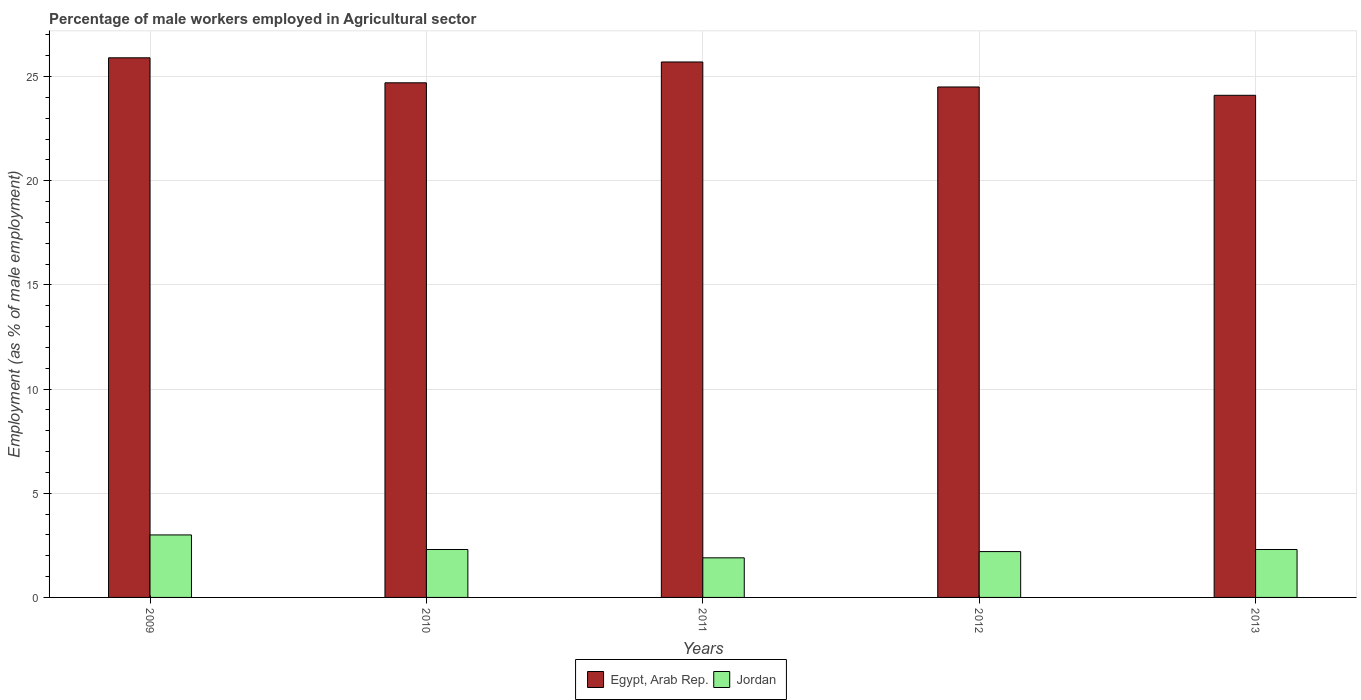How many different coloured bars are there?
Ensure brevity in your answer.  2. Are the number of bars on each tick of the X-axis equal?
Provide a succinct answer. Yes. How many bars are there on the 1st tick from the left?
Keep it short and to the point. 2. What is the percentage of male workers employed in Agricultural sector in Jordan in 2013?
Offer a terse response. 2.3. Across all years, what is the maximum percentage of male workers employed in Agricultural sector in Jordan?
Ensure brevity in your answer.  3. Across all years, what is the minimum percentage of male workers employed in Agricultural sector in Jordan?
Give a very brief answer. 1.9. What is the total percentage of male workers employed in Agricultural sector in Jordan in the graph?
Your response must be concise. 11.7. What is the difference between the percentage of male workers employed in Agricultural sector in Egypt, Arab Rep. in 2009 and that in 2012?
Offer a terse response. 1.4. What is the difference between the percentage of male workers employed in Agricultural sector in Jordan in 2010 and the percentage of male workers employed in Agricultural sector in Egypt, Arab Rep. in 2009?
Give a very brief answer. -23.6. What is the average percentage of male workers employed in Agricultural sector in Egypt, Arab Rep. per year?
Your answer should be very brief. 24.98. In the year 2010, what is the difference between the percentage of male workers employed in Agricultural sector in Jordan and percentage of male workers employed in Agricultural sector in Egypt, Arab Rep.?
Make the answer very short. -22.4. What is the difference between the highest and the second highest percentage of male workers employed in Agricultural sector in Jordan?
Offer a terse response. 0.7. What is the difference between the highest and the lowest percentage of male workers employed in Agricultural sector in Egypt, Arab Rep.?
Make the answer very short. 1.8. In how many years, is the percentage of male workers employed in Agricultural sector in Jordan greater than the average percentage of male workers employed in Agricultural sector in Jordan taken over all years?
Your answer should be compact. 1. What does the 1st bar from the left in 2009 represents?
Give a very brief answer. Egypt, Arab Rep. What does the 2nd bar from the right in 2010 represents?
Offer a very short reply. Egypt, Arab Rep. Are the values on the major ticks of Y-axis written in scientific E-notation?
Provide a short and direct response. No. How many legend labels are there?
Your answer should be very brief. 2. How are the legend labels stacked?
Provide a short and direct response. Horizontal. What is the title of the graph?
Ensure brevity in your answer.  Percentage of male workers employed in Agricultural sector. What is the label or title of the Y-axis?
Offer a terse response. Employment (as % of male employment). What is the Employment (as % of male employment) of Egypt, Arab Rep. in 2009?
Ensure brevity in your answer.  25.9. What is the Employment (as % of male employment) of Egypt, Arab Rep. in 2010?
Your answer should be compact. 24.7. What is the Employment (as % of male employment) of Jordan in 2010?
Make the answer very short. 2.3. What is the Employment (as % of male employment) in Egypt, Arab Rep. in 2011?
Make the answer very short. 25.7. What is the Employment (as % of male employment) in Jordan in 2011?
Keep it short and to the point. 1.9. What is the Employment (as % of male employment) of Jordan in 2012?
Offer a very short reply. 2.2. What is the Employment (as % of male employment) in Egypt, Arab Rep. in 2013?
Give a very brief answer. 24.1. What is the Employment (as % of male employment) of Jordan in 2013?
Your answer should be very brief. 2.3. Across all years, what is the maximum Employment (as % of male employment) in Egypt, Arab Rep.?
Ensure brevity in your answer.  25.9. Across all years, what is the minimum Employment (as % of male employment) in Egypt, Arab Rep.?
Ensure brevity in your answer.  24.1. Across all years, what is the minimum Employment (as % of male employment) of Jordan?
Your response must be concise. 1.9. What is the total Employment (as % of male employment) of Egypt, Arab Rep. in the graph?
Make the answer very short. 124.9. What is the total Employment (as % of male employment) in Jordan in the graph?
Provide a short and direct response. 11.7. What is the difference between the Employment (as % of male employment) of Egypt, Arab Rep. in 2009 and that in 2010?
Your response must be concise. 1.2. What is the difference between the Employment (as % of male employment) in Egypt, Arab Rep. in 2009 and that in 2011?
Make the answer very short. 0.2. What is the difference between the Employment (as % of male employment) of Egypt, Arab Rep. in 2009 and that in 2012?
Your answer should be very brief. 1.4. What is the difference between the Employment (as % of male employment) in Jordan in 2009 and that in 2013?
Give a very brief answer. 0.7. What is the difference between the Employment (as % of male employment) in Jordan in 2010 and that in 2011?
Your answer should be compact. 0.4. What is the difference between the Employment (as % of male employment) of Jordan in 2010 and that in 2013?
Provide a succinct answer. 0. What is the difference between the Employment (as % of male employment) of Egypt, Arab Rep. in 2011 and that in 2012?
Provide a succinct answer. 1.2. What is the difference between the Employment (as % of male employment) of Egypt, Arab Rep. in 2011 and that in 2013?
Ensure brevity in your answer.  1.6. What is the difference between the Employment (as % of male employment) in Jordan in 2011 and that in 2013?
Your answer should be very brief. -0.4. What is the difference between the Employment (as % of male employment) of Egypt, Arab Rep. in 2009 and the Employment (as % of male employment) of Jordan in 2010?
Give a very brief answer. 23.6. What is the difference between the Employment (as % of male employment) in Egypt, Arab Rep. in 2009 and the Employment (as % of male employment) in Jordan in 2012?
Your response must be concise. 23.7. What is the difference between the Employment (as % of male employment) of Egypt, Arab Rep. in 2009 and the Employment (as % of male employment) of Jordan in 2013?
Make the answer very short. 23.6. What is the difference between the Employment (as % of male employment) of Egypt, Arab Rep. in 2010 and the Employment (as % of male employment) of Jordan in 2011?
Offer a very short reply. 22.8. What is the difference between the Employment (as % of male employment) of Egypt, Arab Rep. in 2010 and the Employment (as % of male employment) of Jordan in 2013?
Offer a terse response. 22.4. What is the difference between the Employment (as % of male employment) of Egypt, Arab Rep. in 2011 and the Employment (as % of male employment) of Jordan in 2013?
Keep it short and to the point. 23.4. What is the difference between the Employment (as % of male employment) in Egypt, Arab Rep. in 2012 and the Employment (as % of male employment) in Jordan in 2013?
Offer a terse response. 22.2. What is the average Employment (as % of male employment) in Egypt, Arab Rep. per year?
Offer a very short reply. 24.98. What is the average Employment (as % of male employment) in Jordan per year?
Ensure brevity in your answer.  2.34. In the year 2009, what is the difference between the Employment (as % of male employment) in Egypt, Arab Rep. and Employment (as % of male employment) in Jordan?
Offer a very short reply. 22.9. In the year 2010, what is the difference between the Employment (as % of male employment) of Egypt, Arab Rep. and Employment (as % of male employment) of Jordan?
Provide a succinct answer. 22.4. In the year 2011, what is the difference between the Employment (as % of male employment) of Egypt, Arab Rep. and Employment (as % of male employment) of Jordan?
Provide a short and direct response. 23.8. In the year 2012, what is the difference between the Employment (as % of male employment) of Egypt, Arab Rep. and Employment (as % of male employment) of Jordan?
Provide a short and direct response. 22.3. In the year 2013, what is the difference between the Employment (as % of male employment) of Egypt, Arab Rep. and Employment (as % of male employment) of Jordan?
Your answer should be very brief. 21.8. What is the ratio of the Employment (as % of male employment) of Egypt, Arab Rep. in 2009 to that in 2010?
Offer a terse response. 1.05. What is the ratio of the Employment (as % of male employment) of Jordan in 2009 to that in 2010?
Your answer should be compact. 1.3. What is the ratio of the Employment (as % of male employment) in Jordan in 2009 to that in 2011?
Provide a short and direct response. 1.58. What is the ratio of the Employment (as % of male employment) in Egypt, Arab Rep. in 2009 to that in 2012?
Offer a terse response. 1.06. What is the ratio of the Employment (as % of male employment) in Jordan in 2009 to that in 2012?
Provide a short and direct response. 1.36. What is the ratio of the Employment (as % of male employment) of Egypt, Arab Rep. in 2009 to that in 2013?
Provide a succinct answer. 1.07. What is the ratio of the Employment (as % of male employment) in Jordan in 2009 to that in 2013?
Offer a very short reply. 1.3. What is the ratio of the Employment (as % of male employment) in Egypt, Arab Rep. in 2010 to that in 2011?
Your answer should be compact. 0.96. What is the ratio of the Employment (as % of male employment) in Jordan in 2010 to that in 2011?
Offer a very short reply. 1.21. What is the ratio of the Employment (as % of male employment) of Egypt, Arab Rep. in 2010 to that in 2012?
Your answer should be very brief. 1.01. What is the ratio of the Employment (as % of male employment) in Jordan in 2010 to that in 2012?
Keep it short and to the point. 1.05. What is the ratio of the Employment (as % of male employment) of Egypt, Arab Rep. in 2010 to that in 2013?
Ensure brevity in your answer.  1.02. What is the ratio of the Employment (as % of male employment) of Egypt, Arab Rep. in 2011 to that in 2012?
Make the answer very short. 1.05. What is the ratio of the Employment (as % of male employment) in Jordan in 2011 to that in 2012?
Provide a succinct answer. 0.86. What is the ratio of the Employment (as % of male employment) of Egypt, Arab Rep. in 2011 to that in 2013?
Make the answer very short. 1.07. What is the ratio of the Employment (as % of male employment) in Jordan in 2011 to that in 2013?
Offer a very short reply. 0.83. What is the ratio of the Employment (as % of male employment) in Egypt, Arab Rep. in 2012 to that in 2013?
Your answer should be very brief. 1.02. What is the ratio of the Employment (as % of male employment) of Jordan in 2012 to that in 2013?
Your answer should be compact. 0.96. What is the difference between the highest and the second highest Employment (as % of male employment) in Jordan?
Offer a terse response. 0.7. What is the difference between the highest and the lowest Employment (as % of male employment) of Jordan?
Your response must be concise. 1.1. 